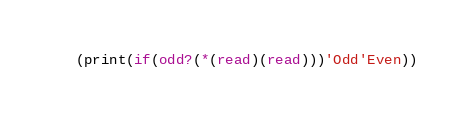Convert code to text. <code><loc_0><loc_0><loc_500><loc_500><_Scheme_>(print(if(odd?(*(read)(read)))'Odd'Even))</code> 